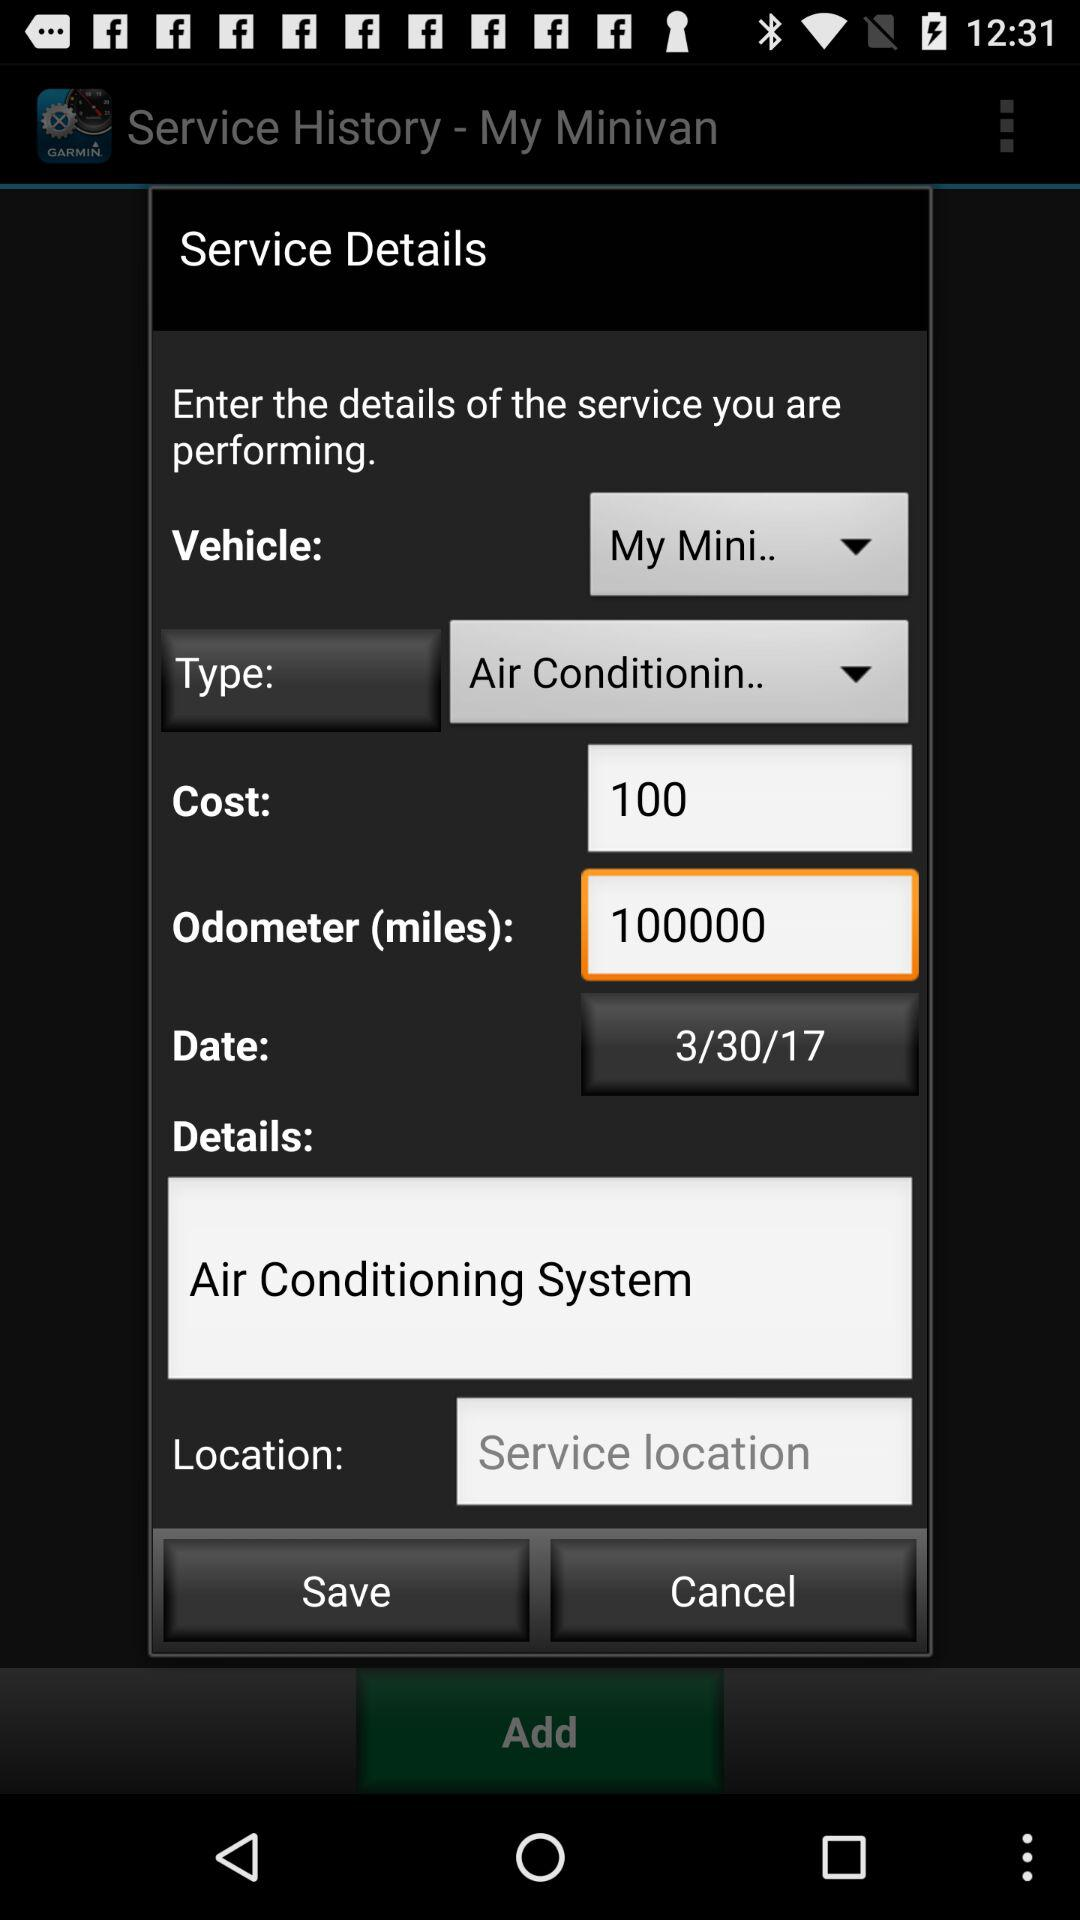What is the cost of service? The cost of service is 100. 